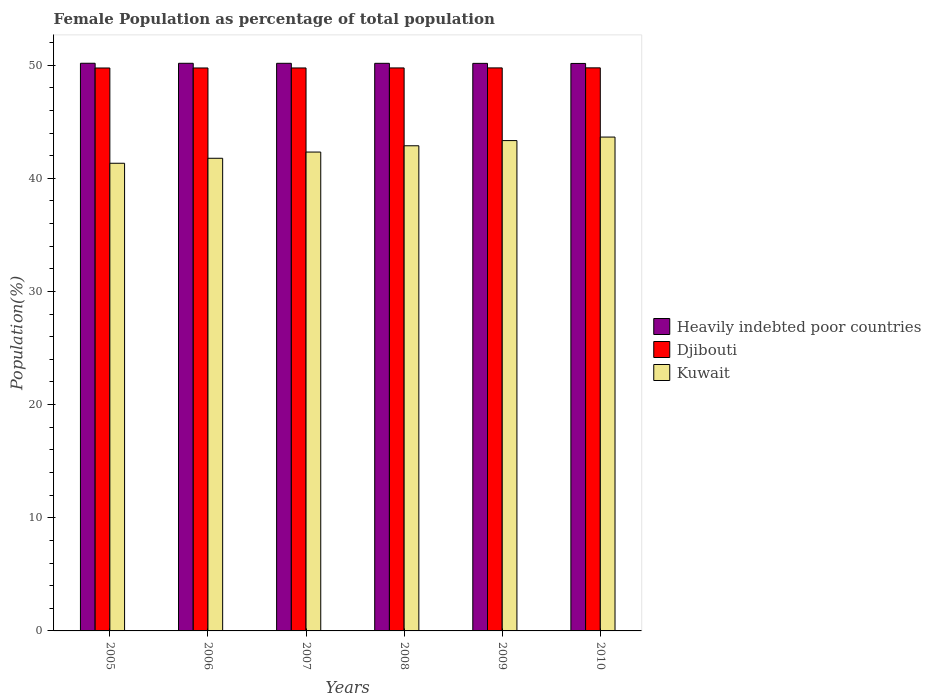How many different coloured bars are there?
Your answer should be very brief. 3. How many groups of bars are there?
Keep it short and to the point. 6. Are the number of bars on each tick of the X-axis equal?
Give a very brief answer. Yes. In how many cases, is the number of bars for a given year not equal to the number of legend labels?
Make the answer very short. 0. What is the female population in in Heavily indebted poor countries in 2007?
Make the answer very short. 50.16. Across all years, what is the maximum female population in in Djibouti?
Offer a terse response. 49.76. Across all years, what is the minimum female population in in Djibouti?
Your answer should be very brief. 49.74. In which year was the female population in in Heavily indebted poor countries maximum?
Provide a short and direct response. 2005. What is the total female population in in Djibouti in the graph?
Your response must be concise. 298.5. What is the difference between the female population in in Kuwait in 2009 and that in 2010?
Keep it short and to the point. -0.31. What is the difference between the female population in in Djibouti in 2008 and the female population in in Heavily indebted poor countries in 2009?
Offer a terse response. -0.4. What is the average female population in in Djibouti per year?
Keep it short and to the point. 49.75. In the year 2005, what is the difference between the female population in in Djibouti and female population in in Kuwait?
Keep it short and to the point. 8.42. What is the ratio of the female population in in Heavily indebted poor countries in 2009 to that in 2010?
Provide a succinct answer. 1. What is the difference between the highest and the second highest female population in in Heavily indebted poor countries?
Offer a terse response. 0. What is the difference between the highest and the lowest female population in in Kuwait?
Your answer should be very brief. 2.31. In how many years, is the female population in in Djibouti greater than the average female population in in Djibouti taken over all years?
Provide a succinct answer. 3. What does the 2nd bar from the left in 2006 represents?
Your answer should be very brief. Djibouti. What does the 3rd bar from the right in 2005 represents?
Make the answer very short. Heavily indebted poor countries. Is it the case that in every year, the sum of the female population in in Kuwait and female population in in Djibouti is greater than the female population in in Heavily indebted poor countries?
Make the answer very short. Yes. Does the graph contain any zero values?
Your answer should be compact. No. Where does the legend appear in the graph?
Provide a short and direct response. Center right. How many legend labels are there?
Your answer should be compact. 3. What is the title of the graph?
Make the answer very short. Female Population as percentage of total population. Does "Saudi Arabia" appear as one of the legend labels in the graph?
Keep it short and to the point. No. What is the label or title of the X-axis?
Make the answer very short. Years. What is the label or title of the Y-axis?
Your answer should be very brief. Population(%). What is the Population(%) in Heavily indebted poor countries in 2005?
Your answer should be compact. 50.16. What is the Population(%) in Djibouti in 2005?
Provide a succinct answer. 49.74. What is the Population(%) of Kuwait in 2005?
Your answer should be compact. 41.33. What is the Population(%) of Heavily indebted poor countries in 2006?
Your answer should be compact. 50.16. What is the Population(%) of Djibouti in 2006?
Offer a very short reply. 49.75. What is the Population(%) in Kuwait in 2006?
Ensure brevity in your answer.  41.77. What is the Population(%) of Heavily indebted poor countries in 2007?
Your answer should be very brief. 50.16. What is the Population(%) of Djibouti in 2007?
Provide a succinct answer. 49.75. What is the Population(%) in Kuwait in 2007?
Give a very brief answer. 42.32. What is the Population(%) of Heavily indebted poor countries in 2008?
Offer a very short reply. 50.16. What is the Population(%) in Djibouti in 2008?
Your response must be concise. 49.75. What is the Population(%) in Kuwait in 2008?
Keep it short and to the point. 42.87. What is the Population(%) of Heavily indebted poor countries in 2009?
Provide a short and direct response. 50.15. What is the Population(%) of Djibouti in 2009?
Make the answer very short. 49.75. What is the Population(%) in Kuwait in 2009?
Ensure brevity in your answer.  43.33. What is the Population(%) of Heavily indebted poor countries in 2010?
Provide a succinct answer. 50.15. What is the Population(%) of Djibouti in 2010?
Give a very brief answer. 49.76. What is the Population(%) of Kuwait in 2010?
Provide a succinct answer. 43.64. Across all years, what is the maximum Population(%) in Heavily indebted poor countries?
Your answer should be compact. 50.16. Across all years, what is the maximum Population(%) in Djibouti?
Ensure brevity in your answer.  49.76. Across all years, what is the maximum Population(%) of Kuwait?
Your response must be concise. 43.64. Across all years, what is the minimum Population(%) in Heavily indebted poor countries?
Make the answer very short. 50.15. Across all years, what is the minimum Population(%) in Djibouti?
Ensure brevity in your answer.  49.74. Across all years, what is the minimum Population(%) of Kuwait?
Provide a succinct answer. 41.33. What is the total Population(%) in Heavily indebted poor countries in the graph?
Ensure brevity in your answer.  300.94. What is the total Population(%) in Djibouti in the graph?
Ensure brevity in your answer.  298.5. What is the total Population(%) in Kuwait in the graph?
Provide a succinct answer. 255.25. What is the difference between the Population(%) of Heavily indebted poor countries in 2005 and that in 2006?
Your response must be concise. 0. What is the difference between the Population(%) of Djibouti in 2005 and that in 2006?
Provide a short and direct response. -0. What is the difference between the Population(%) of Kuwait in 2005 and that in 2006?
Your answer should be very brief. -0.44. What is the difference between the Population(%) of Heavily indebted poor countries in 2005 and that in 2007?
Make the answer very short. 0. What is the difference between the Population(%) in Djibouti in 2005 and that in 2007?
Give a very brief answer. -0. What is the difference between the Population(%) of Kuwait in 2005 and that in 2007?
Offer a terse response. -0.99. What is the difference between the Population(%) of Heavily indebted poor countries in 2005 and that in 2008?
Offer a very short reply. 0.01. What is the difference between the Population(%) in Djibouti in 2005 and that in 2008?
Your response must be concise. -0.01. What is the difference between the Population(%) in Kuwait in 2005 and that in 2008?
Provide a succinct answer. -1.55. What is the difference between the Population(%) in Heavily indebted poor countries in 2005 and that in 2009?
Your response must be concise. 0.01. What is the difference between the Population(%) of Djibouti in 2005 and that in 2009?
Your answer should be compact. -0.01. What is the difference between the Population(%) in Kuwait in 2005 and that in 2009?
Provide a succinct answer. -2. What is the difference between the Population(%) in Heavily indebted poor countries in 2005 and that in 2010?
Your answer should be very brief. 0.02. What is the difference between the Population(%) in Djibouti in 2005 and that in 2010?
Give a very brief answer. -0.01. What is the difference between the Population(%) in Kuwait in 2005 and that in 2010?
Offer a terse response. -2.31. What is the difference between the Population(%) in Heavily indebted poor countries in 2006 and that in 2007?
Give a very brief answer. 0. What is the difference between the Population(%) in Djibouti in 2006 and that in 2007?
Ensure brevity in your answer.  -0. What is the difference between the Population(%) of Kuwait in 2006 and that in 2007?
Ensure brevity in your answer.  -0.55. What is the difference between the Population(%) of Heavily indebted poor countries in 2006 and that in 2008?
Your answer should be very brief. 0. What is the difference between the Population(%) in Djibouti in 2006 and that in 2008?
Give a very brief answer. -0. What is the difference between the Population(%) in Kuwait in 2006 and that in 2008?
Your answer should be compact. -1.11. What is the difference between the Population(%) in Heavily indebted poor countries in 2006 and that in 2009?
Keep it short and to the point. 0.01. What is the difference between the Population(%) in Djibouti in 2006 and that in 2009?
Ensure brevity in your answer.  -0.01. What is the difference between the Population(%) of Kuwait in 2006 and that in 2009?
Your answer should be compact. -1.56. What is the difference between the Population(%) of Heavily indebted poor countries in 2006 and that in 2010?
Provide a short and direct response. 0.01. What is the difference between the Population(%) in Djibouti in 2006 and that in 2010?
Ensure brevity in your answer.  -0.01. What is the difference between the Population(%) of Kuwait in 2006 and that in 2010?
Ensure brevity in your answer.  -1.87. What is the difference between the Population(%) in Heavily indebted poor countries in 2007 and that in 2008?
Your answer should be compact. 0. What is the difference between the Population(%) of Djibouti in 2007 and that in 2008?
Offer a terse response. -0. What is the difference between the Population(%) in Kuwait in 2007 and that in 2008?
Provide a short and direct response. -0.56. What is the difference between the Population(%) of Heavily indebted poor countries in 2007 and that in 2009?
Your response must be concise. 0.01. What is the difference between the Population(%) in Djibouti in 2007 and that in 2009?
Your answer should be compact. -0.01. What is the difference between the Population(%) in Kuwait in 2007 and that in 2009?
Your answer should be very brief. -1.01. What is the difference between the Population(%) in Heavily indebted poor countries in 2007 and that in 2010?
Your answer should be compact. 0.01. What is the difference between the Population(%) of Djibouti in 2007 and that in 2010?
Your answer should be very brief. -0.01. What is the difference between the Population(%) of Kuwait in 2007 and that in 2010?
Your response must be concise. -1.32. What is the difference between the Population(%) of Heavily indebted poor countries in 2008 and that in 2009?
Keep it short and to the point. 0. What is the difference between the Population(%) of Djibouti in 2008 and that in 2009?
Ensure brevity in your answer.  -0. What is the difference between the Population(%) of Kuwait in 2008 and that in 2009?
Your response must be concise. -0.46. What is the difference between the Population(%) of Heavily indebted poor countries in 2008 and that in 2010?
Provide a short and direct response. 0.01. What is the difference between the Population(%) in Djibouti in 2008 and that in 2010?
Keep it short and to the point. -0.01. What is the difference between the Population(%) in Kuwait in 2008 and that in 2010?
Offer a terse response. -0.77. What is the difference between the Population(%) in Heavily indebted poor countries in 2009 and that in 2010?
Make the answer very short. 0.01. What is the difference between the Population(%) in Djibouti in 2009 and that in 2010?
Your response must be concise. -0. What is the difference between the Population(%) in Kuwait in 2009 and that in 2010?
Give a very brief answer. -0.31. What is the difference between the Population(%) in Heavily indebted poor countries in 2005 and the Population(%) in Djibouti in 2006?
Offer a terse response. 0.42. What is the difference between the Population(%) of Heavily indebted poor countries in 2005 and the Population(%) of Kuwait in 2006?
Provide a short and direct response. 8.4. What is the difference between the Population(%) in Djibouti in 2005 and the Population(%) in Kuwait in 2006?
Provide a short and direct response. 7.98. What is the difference between the Population(%) of Heavily indebted poor countries in 2005 and the Population(%) of Djibouti in 2007?
Your answer should be compact. 0.42. What is the difference between the Population(%) of Heavily indebted poor countries in 2005 and the Population(%) of Kuwait in 2007?
Make the answer very short. 7.85. What is the difference between the Population(%) of Djibouti in 2005 and the Population(%) of Kuwait in 2007?
Give a very brief answer. 7.43. What is the difference between the Population(%) of Heavily indebted poor countries in 2005 and the Population(%) of Djibouti in 2008?
Give a very brief answer. 0.41. What is the difference between the Population(%) in Heavily indebted poor countries in 2005 and the Population(%) in Kuwait in 2008?
Give a very brief answer. 7.29. What is the difference between the Population(%) in Djibouti in 2005 and the Population(%) in Kuwait in 2008?
Offer a terse response. 6.87. What is the difference between the Population(%) of Heavily indebted poor countries in 2005 and the Population(%) of Djibouti in 2009?
Offer a very short reply. 0.41. What is the difference between the Population(%) in Heavily indebted poor countries in 2005 and the Population(%) in Kuwait in 2009?
Your answer should be compact. 6.83. What is the difference between the Population(%) in Djibouti in 2005 and the Population(%) in Kuwait in 2009?
Provide a succinct answer. 6.41. What is the difference between the Population(%) in Heavily indebted poor countries in 2005 and the Population(%) in Djibouti in 2010?
Offer a terse response. 0.41. What is the difference between the Population(%) of Heavily indebted poor countries in 2005 and the Population(%) of Kuwait in 2010?
Your answer should be very brief. 6.52. What is the difference between the Population(%) in Djibouti in 2005 and the Population(%) in Kuwait in 2010?
Your answer should be very brief. 6.1. What is the difference between the Population(%) of Heavily indebted poor countries in 2006 and the Population(%) of Djibouti in 2007?
Make the answer very short. 0.41. What is the difference between the Population(%) in Heavily indebted poor countries in 2006 and the Population(%) in Kuwait in 2007?
Provide a succinct answer. 7.84. What is the difference between the Population(%) in Djibouti in 2006 and the Population(%) in Kuwait in 2007?
Make the answer very short. 7.43. What is the difference between the Population(%) of Heavily indebted poor countries in 2006 and the Population(%) of Djibouti in 2008?
Provide a short and direct response. 0.41. What is the difference between the Population(%) in Heavily indebted poor countries in 2006 and the Population(%) in Kuwait in 2008?
Your answer should be very brief. 7.29. What is the difference between the Population(%) in Djibouti in 2006 and the Population(%) in Kuwait in 2008?
Your answer should be compact. 6.87. What is the difference between the Population(%) in Heavily indebted poor countries in 2006 and the Population(%) in Djibouti in 2009?
Offer a very short reply. 0.41. What is the difference between the Population(%) of Heavily indebted poor countries in 2006 and the Population(%) of Kuwait in 2009?
Make the answer very short. 6.83. What is the difference between the Population(%) of Djibouti in 2006 and the Population(%) of Kuwait in 2009?
Make the answer very short. 6.42. What is the difference between the Population(%) in Heavily indebted poor countries in 2006 and the Population(%) in Djibouti in 2010?
Your response must be concise. 0.4. What is the difference between the Population(%) in Heavily indebted poor countries in 2006 and the Population(%) in Kuwait in 2010?
Provide a succinct answer. 6.52. What is the difference between the Population(%) of Djibouti in 2006 and the Population(%) of Kuwait in 2010?
Give a very brief answer. 6.11. What is the difference between the Population(%) of Heavily indebted poor countries in 2007 and the Population(%) of Djibouti in 2008?
Provide a short and direct response. 0.41. What is the difference between the Population(%) of Heavily indebted poor countries in 2007 and the Population(%) of Kuwait in 2008?
Provide a short and direct response. 7.29. What is the difference between the Population(%) in Djibouti in 2007 and the Population(%) in Kuwait in 2008?
Your answer should be compact. 6.88. What is the difference between the Population(%) in Heavily indebted poor countries in 2007 and the Population(%) in Djibouti in 2009?
Offer a terse response. 0.41. What is the difference between the Population(%) of Heavily indebted poor countries in 2007 and the Population(%) of Kuwait in 2009?
Provide a short and direct response. 6.83. What is the difference between the Population(%) in Djibouti in 2007 and the Population(%) in Kuwait in 2009?
Make the answer very short. 6.42. What is the difference between the Population(%) in Heavily indebted poor countries in 2007 and the Population(%) in Djibouti in 2010?
Offer a very short reply. 0.4. What is the difference between the Population(%) of Heavily indebted poor countries in 2007 and the Population(%) of Kuwait in 2010?
Provide a short and direct response. 6.52. What is the difference between the Population(%) of Djibouti in 2007 and the Population(%) of Kuwait in 2010?
Give a very brief answer. 6.11. What is the difference between the Population(%) in Heavily indebted poor countries in 2008 and the Population(%) in Djibouti in 2009?
Your response must be concise. 0.4. What is the difference between the Population(%) of Heavily indebted poor countries in 2008 and the Population(%) of Kuwait in 2009?
Your answer should be very brief. 6.83. What is the difference between the Population(%) in Djibouti in 2008 and the Population(%) in Kuwait in 2009?
Offer a very short reply. 6.42. What is the difference between the Population(%) in Heavily indebted poor countries in 2008 and the Population(%) in Djibouti in 2010?
Your answer should be compact. 0.4. What is the difference between the Population(%) of Heavily indebted poor countries in 2008 and the Population(%) of Kuwait in 2010?
Provide a succinct answer. 6.52. What is the difference between the Population(%) in Djibouti in 2008 and the Population(%) in Kuwait in 2010?
Offer a terse response. 6.11. What is the difference between the Population(%) of Heavily indebted poor countries in 2009 and the Population(%) of Djibouti in 2010?
Provide a short and direct response. 0.4. What is the difference between the Population(%) in Heavily indebted poor countries in 2009 and the Population(%) in Kuwait in 2010?
Make the answer very short. 6.51. What is the difference between the Population(%) in Djibouti in 2009 and the Population(%) in Kuwait in 2010?
Your response must be concise. 6.11. What is the average Population(%) of Heavily indebted poor countries per year?
Provide a short and direct response. 50.16. What is the average Population(%) of Djibouti per year?
Ensure brevity in your answer.  49.75. What is the average Population(%) of Kuwait per year?
Ensure brevity in your answer.  42.54. In the year 2005, what is the difference between the Population(%) in Heavily indebted poor countries and Population(%) in Djibouti?
Provide a succinct answer. 0.42. In the year 2005, what is the difference between the Population(%) of Heavily indebted poor countries and Population(%) of Kuwait?
Provide a short and direct response. 8.84. In the year 2005, what is the difference between the Population(%) in Djibouti and Population(%) in Kuwait?
Give a very brief answer. 8.42. In the year 2006, what is the difference between the Population(%) of Heavily indebted poor countries and Population(%) of Djibouti?
Make the answer very short. 0.41. In the year 2006, what is the difference between the Population(%) in Heavily indebted poor countries and Population(%) in Kuwait?
Ensure brevity in your answer.  8.39. In the year 2006, what is the difference between the Population(%) of Djibouti and Population(%) of Kuwait?
Provide a short and direct response. 7.98. In the year 2007, what is the difference between the Population(%) in Heavily indebted poor countries and Population(%) in Djibouti?
Provide a succinct answer. 0.41. In the year 2007, what is the difference between the Population(%) in Heavily indebted poor countries and Population(%) in Kuwait?
Offer a terse response. 7.84. In the year 2007, what is the difference between the Population(%) of Djibouti and Population(%) of Kuwait?
Your response must be concise. 7.43. In the year 2008, what is the difference between the Population(%) in Heavily indebted poor countries and Population(%) in Djibouti?
Give a very brief answer. 0.41. In the year 2008, what is the difference between the Population(%) of Heavily indebted poor countries and Population(%) of Kuwait?
Your answer should be compact. 7.29. In the year 2008, what is the difference between the Population(%) in Djibouti and Population(%) in Kuwait?
Ensure brevity in your answer.  6.88. In the year 2009, what is the difference between the Population(%) of Heavily indebted poor countries and Population(%) of Djibouti?
Your answer should be very brief. 0.4. In the year 2009, what is the difference between the Population(%) in Heavily indebted poor countries and Population(%) in Kuwait?
Offer a very short reply. 6.82. In the year 2009, what is the difference between the Population(%) in Djibouti and Population(%) in Kuwait?
Offer a terse response. 6.42. In the year 2010, what is the difference between the Population(%) in Heavily indebted poor countries and Population(%) in Djibouti?
Make the answer very short. 0.39. In the year 2010, what is the difference between the Population(%) of Heavily indebted poor countries and Population(%) of Kuwait?
Provide a succinct answer. 6.51. In the year 2010, what is the difference between the Population(%) in Djibouti and Population(%) in Kuwait?
Your response must be concise. 6.12. What is the ratio of the Population(%) of Kuwait in 2005 to that in 2006?
Provide a succinct answer. 0.99. What is the ratio of the Population(%) in Kuwait in 2005 to that in 2007?
Your answer should be very brief. 0.98. What is the ratio of the Population(%) in Heavily indebted poor countries in 2005 to that in 2008?
Give a very brief answer. 1. What is the ratio of the Population(%) in Djibouti in 2005 to that in 2008?
Your response must be concise. 1. What is the ratio of the Population(%) of Djibouti in 2005 to that in 2009?
Offer a terse response. 1. What is the ratio of the Population(%) of Kuwait in 2005 to that in 2009?
Give a very brief answer. 0.95. What is the ratio of the Population(%) of Djibouti in 2005 to that in 2010?
Offer a terse response. 1. What is the ratio of the Population(%) of Kuwait in 2005 to that in 2010?
Ensure brevity in your answer.  0.95. What is the ratio of the Population(%) in Heavily indebted poor countries in 2006 to that in 2007?
Your response must be concise. 1. What is the ratio of the Population(%) of Kuwait in 2006 to that in 2007?
Give a very brief answer. 0.99. What is the ratio of the Population(%) of Kuwait in 2006 to that in 2008?
Provide a short and direct response. 0.97. What is the ratio of the Population(%) in Djibouti in 2006 to that in 2009?
Ensure brevity in your answer.  1. What is the ratio of the Population(%) of Kuwait in 2006 to that in 2009?
Provide a succinct answer. 0.96. What is the ratio of the Population(%) in Djibouti in 2007 to that in 2008?
Your response must be concise. 1. What is the ratio of the Population(%) of Heavily indebted poor countries in 2007 to that in 2009?
Keep it short and to the point. 1. What is the ratio of the Population(%) in Kuwait in 2007 to that in 2009?
Your answer should be very brief. 0.98. What is the ratio of the Population(%) of Djibouti in 2007 to that in 2010?
Provide a short and direct response. 1. What is the ratio of the Population(%) of Kuwait in 2007 to that in 2010?
Offer a terse response. 0.97. What is the ratio of the Population(%) in Djibouti in 2008 to that in 2009?
Keep it short and to the point. 1. What is the ratio of the Population(%) in Kuwait in 2008 to that in 2009?
Keep it short and to the point. 0.99. What is the ratio of the Population(%) in Kuwait in 2008 to that in 2010?
Give a very brief answer. 0.98. What is the ratio of the Population(%) of Heavily indebted poor countries in 2009 to that in 2010?
Your response must be concise. 1. What is the ratio of the Population(%) of Djibouti in 2009 to that in 2010?
Make the answer very short. 1. What is the difference between the highest and the second highest Population(%) of Heavily indebted poor countries?
Make the answer very short. 0. What is the difference between the highest and the second highest Population(%) in Djibouti?
Give a very brief answer. 0. What is the difference between the highest and the second highest Population(%) in Kuwait?
Keep it short and to the point. 0.31. What is the difference between the highest and the lowest Population(%) in Heavily indebted poor countries?
Offer a very short reply. 0.02. What is the difference between the highest and the lowest Population(%) in Djibouti?
Keep it short and to the point. 0.01. What is the difference between the highest and the lowest Population(%) of Kuwait?
Your answer should be compact. 2.31. 